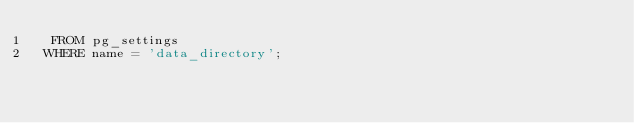Convert code to text. <code><loc_0><loc_0><loc_500><loc_500><_SQL_>  FROM pg_settings
 WHERE name = 'data_directory';
</code> 